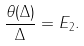<formula> <loc_0><loc_0><loc_500><loc_500>\frac { \theta ( \Delta ) } { \Delta } = E _ { 2 } .</formula> 